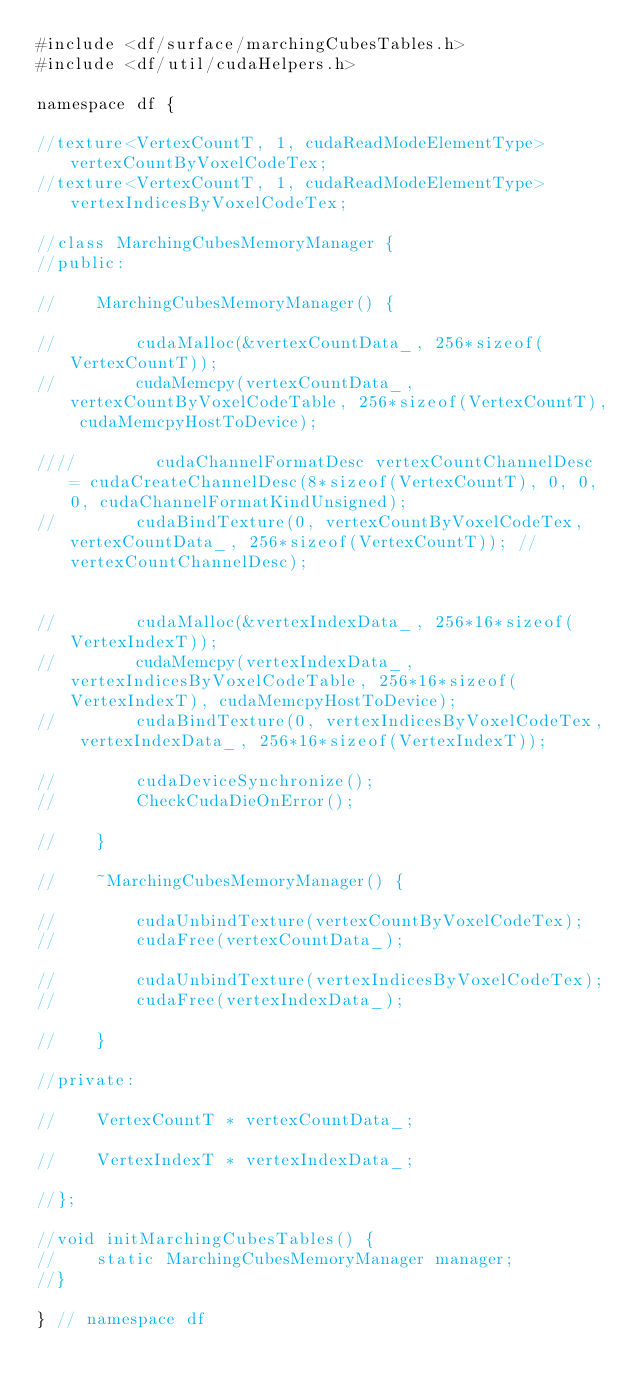Convert code to text. <code><loc_0><loc_0><loc_500><loc_500><_Cuda_>#include <df/surface/marchingCubesTables.h>
#include <df/util/cudaHelpers.h>

namespace df {

//texture<VertexCountT, 1, cudaReadModeElementType> vertexCountByVoxelCodeTex;
//texture<VertexCountT, 1, cudaReadModeElementType> vertexIndicesByVoxelCodeTex;

//class MarchingCubesMemoryManager {
//public:

//    MarchingCubesMemoryManager() {

//        cudaMalloc(&vertexCountData_, 256*sizeof(VertexCountT));
//        cudaMemcpy(vertexCountData_, vertexCountByVoxelCodeTable, 256*sizeof(VertexCountT), cudaMemcpyHostToDevice);

////        cudaChannelFormatDesc vertexCountChannelDesc = cudaCreateChannelDesc(8*sizeof(VertexCountT), 0, 0, 0, cudaChannelFormatKindUnsigned);
//        cudaBindTexture(0, vertexCountByVoxelCodeTex, vertexCountData_, 256*sizeof(VertexCountT)); //vertexCountChannelDesc);


//        cudaMalloc(&vertexIndexData_, 256*16*sizeof(VertexIndexT));
//        cudaMemcpy(vertexIndexData_, vertexIndicesByVoxelCodeTable, 256*16*sizeof(VertexIndexT), cudaMemcpyHostToDevice);
//        cudaBindTexture(0, vertexIndicesByVoxelCodeTex, vertexIndexData_, 256*16*sizeof(VertexIndexT));

//        cudaDeviceSynchronize();
//        CheckCudaDieOnError();

//    }

//    ~MarchingCubesMemoryManager() {

//        cudaUnbindTexture(vertexCountByVoxelCodeTex);
//        cudaFree(vertexCountData_);

//        cudaUnbindTexture(vertexIndicesByVoxelCodeTex);
//        cudaFree(vertexIndexData_);

//    }

//private:

//    VertexCountT * vertexCountData_;

//    VertexIndexT * vertexIndexData_;

//};

//void initMarchingCubesTables() {
//    static MarchingCubesMemoryManager manager;
//}

} // namespace df
</code> 